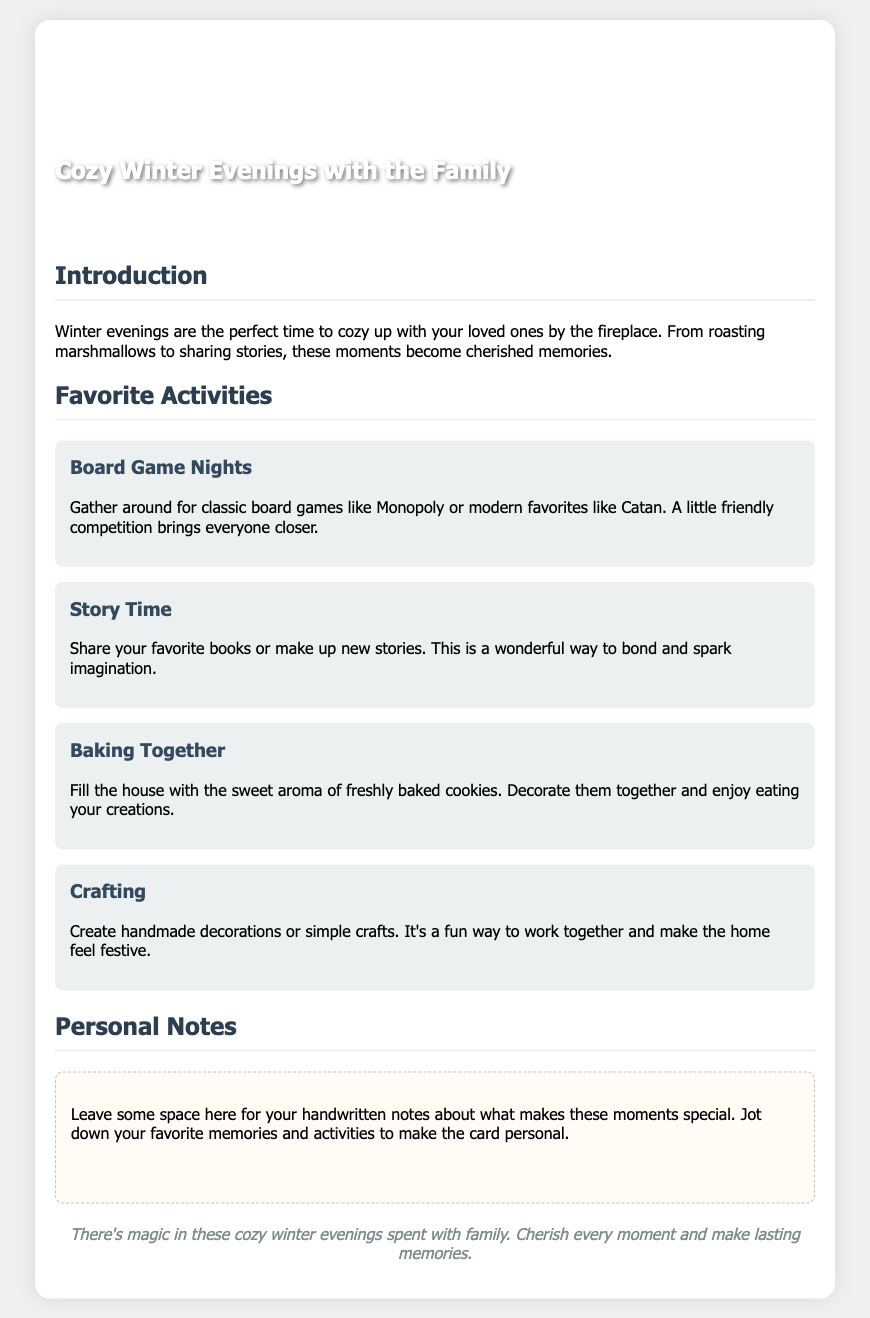What is the title of the card? The title of the card is displayed prominently at the top of the document, indicating the theme.
Answer: Cozy Winter Evenings with the Family What is one recommended activity for winter evenings? The document lists several activities, one of which is highlighted as a suggestion for family time.
Answer: Board Game Nights How many favorite activities are listed in the document? The document enumerates several activities that families can enjoy together, which can be counted directly from the text.
Answer: Four What is mentioned as a beneficial aspect of winter evenings? The text includes information about the positive outcomes of spending time together during winter evenings.
Answer: Cherished memories What type of notes can you write on this card? The document encourages personal reflections and memories, which can be noted down in a designated space.
Answer: Handwritten notes What color is used for the background of the card? The document describes the background color utilized throughout the card design.
Answer: White What does “Baking Together” involve according to the card? The document elaborates on the activity "Baking Together" as a way to bond and have fun with family members.
Answer: Baking cookies What type of document is this? The overall purpose of the document can be determined by its themes and functionalities.
Answer: Greeting card 